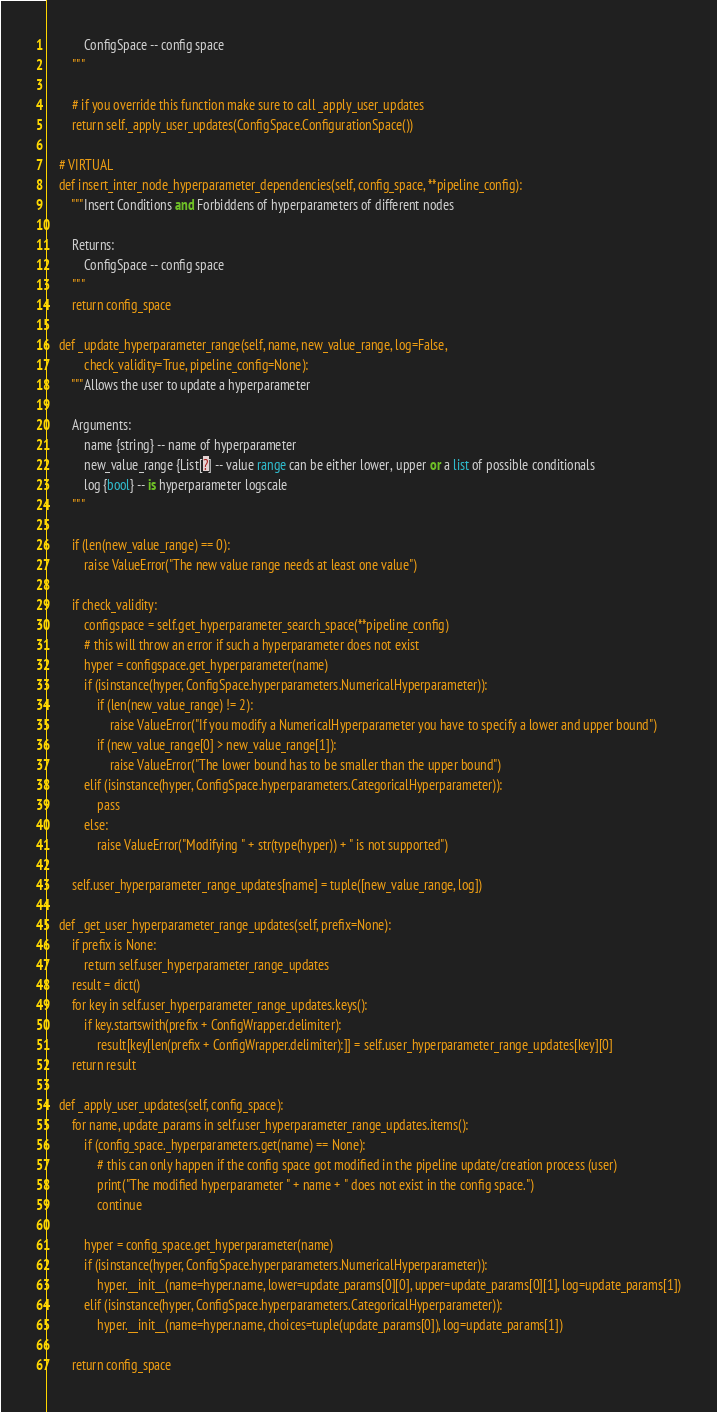Convert code to text. <code><loc_0><loc_0><loc_500><loc_500><_Python_>            ConfigSpace -- config space
        """

        # if you override this function make sure to call _apply_user_updates
        return self._apply_user_updates(ConfigSpace.ConfigurationSpace())
    
    # VIRTUAL
    def insert_inter_node_hyperparameter_dependencies(self, config_space, **pipeline_config):
        """Insert Conditions and Forbiddens of hyperparameters of different nodes

        Returns:
            ConfigSpace -- config space
        """
        return config_space

    def _update_hyperparameter_range(self, name, new_value_range, log=False,
            check_validity=True, pipeline_config=None):
        """Allows the user to update a hyperparameter
        
        Arguments:
            name {string} -- name of hyperparameter
            new_value_range {List[?] -- value range can be either lower, upper or a list of possible conditionals
            log {bool} -- is hyperparameter logscale
        """

        if (len(new_value_range) == 0):
            raise ValueError("The new value range needs at least one value")

        if check_validity:
            configspace = self.get_hyperparameter_search_space(**pipeline_config)
            # this will throw an error if such a hyperparameter does not exist
            hyper = configspace.get_hyperparameter(name)
            if (isinstance(hyper, ConfigSpace.hyperparameters.NumericalHyperparameter)):
                if (len(new_value_range) != 2):
                    raise ValueError("If you modify a NumericalHyperparameter you have to specify a lower and upper bound")
                if (new_value_range[0] > new_value_range[1]):
                    raise ValueError("The lower bound has to be smaller than the upper bound")
            elif (isinstance(hyper, ConfigSpace.hyperparameters.CategoricalHyperparameter)):
                pass
            else:
                raise ValueError("Modifying " + str(type(hyper)) + " is not supported")

        self.user_hyperparameter_range_updates[name] = tuple([new_value_range, log])
    
    def _get_user_hyperparameter_range_updates(self, prefix=None):
        if prefix is None:
            return self.user_hyperparameter_range_updates
        result = dict()
        for key in self.user_hyperparameter_range_updates.keys():
            if key.startswith(prefix + ConfigWrapper.delimiter):
                result[key[len(prefix + ConfigWrapper.delimiter):]] = self.user_hyperparameter_range_updates[key][0]
        return result

    def _apply_user_updates(self, config_space):
        for name, update_params in self.user_hyperparameter_range_updates.items():
            if (config_space._hyperparameters.get(name) == None):
                # this can only happen if the config space got modified in the pipeline update/creation process (user)
                print("The modified hyperparameter " + name + " does not exist in the config space.")
                continue

            hyper = config_space.get_hyperparameter(name)
            if (isinstance(hyper, ConfigSpace.hyperparameters.NumericalHyperparameter)):
                hyper.__init__(name=hyper.name, lower=update_params[0][0], upper=update_params[0][1], log=update_params[1])
            elif (isinstance(hyper, ConfigSpace.hyperparameters.CategoricalHyperparameter)):
                hyper.__init__(name=hyper.name, choices=tuple(update_params[0]), log=update_params[1])

        return config_space

</code> 